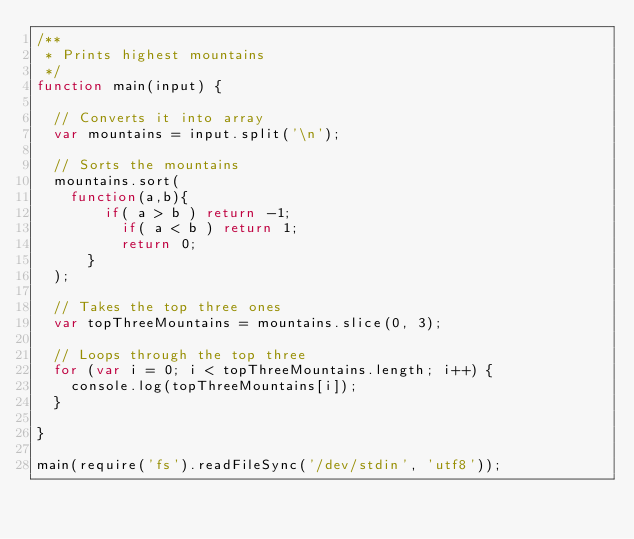<code> <loc_0><loc_0><loc_500><loc_500><_JavaScript_>/**
 * Prints highest mountains
 */
function main(input) {

  // Converts it into array
  var mountains = input.split('\n');

  // Sorts the mountains
  mountains.sort(
    function(a,b){
        if( a > b ) return -1;
          if( a < b ) return 1;
          return 0;
      }
  );

  // Takes the top three ones
  var topThreeMountains = mountains.slice(0, 3);

  // Loops through the top three
  for (var i = 0; i < topThreeMountains.length; i++) {
    console.log(topThreeMountains[i]);
  }

}

main(require('fs').readFileSync('/dev/stdin', 'utf8'));</code> 